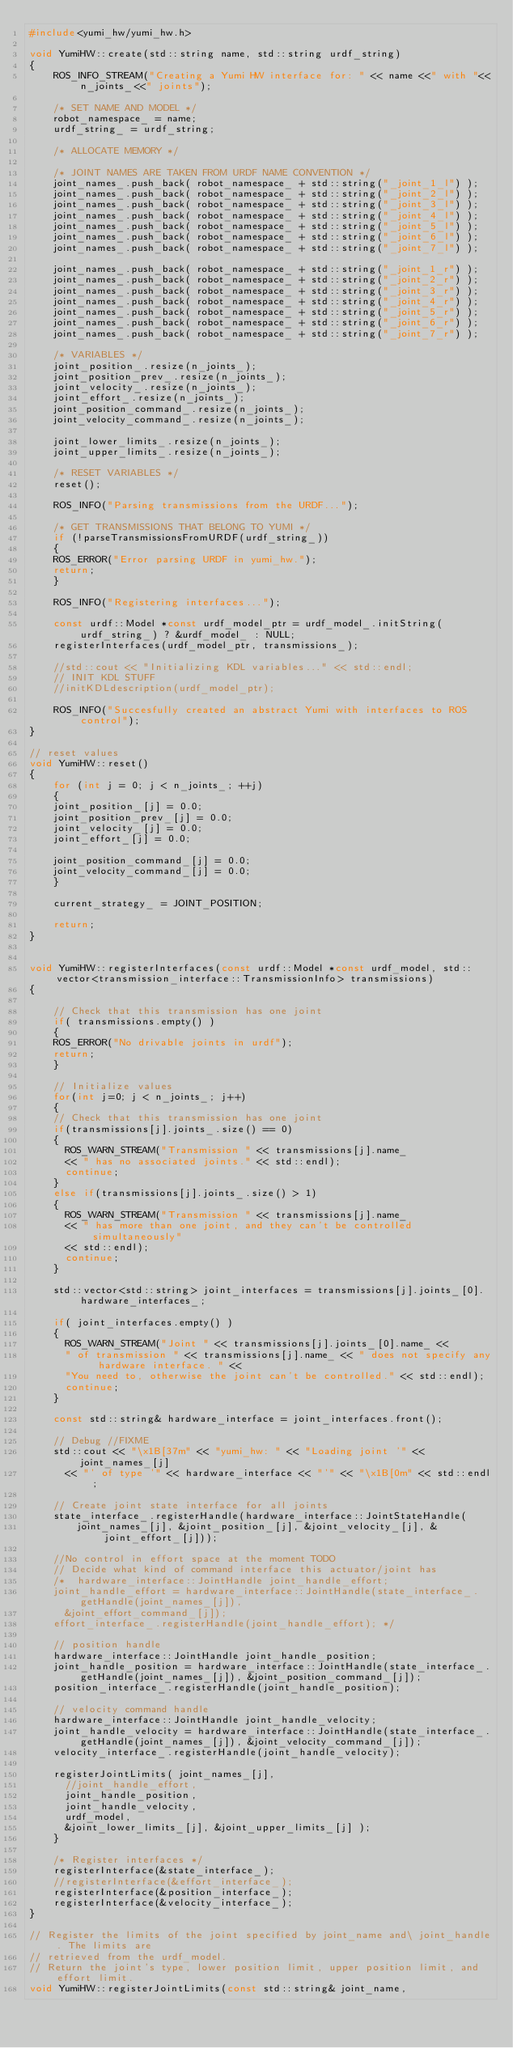<code> <loc_0><loc_0><loc_500><loc_500><_C++_>#include<yumi_hw/yumi_hw.h>

void YumiHW::create(std::string name, std::string urdf_string)
{
    ROS_INFO_STREAM("Creating a Yumi HW interface for: " << name <<" with "<<n_joints_<<" joints");

    /* SET NAME AND MODEL */
    robot_namespace_ = name;
    urdf_string_ = urdf_string;

    /* ALLOCATE MEMORY */

    /* JOINT NAMES ARE TAKEN FROM URDF NAME CONVENTION */
    joint_names_.push_back( robot_namespace_ + std::string("_joint_1_l") );
    joint_names_.push_back( robot_namespace_ + std::string("_joint_2_l") );
    joint_names_.push_back( robot_namespace_ + std::string("_joint_3_l") );
    joint_names_.push_back( robot_namespace_ + std::string("_joint_4_l") );
    joint_names_.push_back( robot_namespace_ + std::string("_joint_5_l") );
    joint_names_.push_back( robot_namespace_ + std::string("_joint_6_l") );
    joint_names_.push_back( robot_namespace_ + std::string("_joint_7_l") );
    
    joint_names_.push_back( robot_namespace_ + std::string("_joint_1_r") );
    joint_names_.push_back( robot_namespace_ + std::string("_joint_2_r") );
    joint_names_.push_back( robot_namespace_ + std::string("_joint_3_r") );
    joint_names_.push_back( robot_namespace_ + std::string("_joint_4_r") );
    joint_names_.push_back( robot_namespace_ + std::string("_joint_5_r") );
    joint_names_.push_back( robot_namespace_ + std::string("_joint_6_r") );
    joint_names_.push_back( robot_namespace_ + std::string("_joint_7_r") );
    
    /* VARIABLES */
    joint_position_.resize(n_joints_);
    joint_position_prev_.resize(n_joints_);
    joint_velocity_.resize(n_joints_);
    joint_effort_.resize(n_joints_);
    joint_position_command_.resize(n_joints_);
    joint_velocity_command_.resize(n_joints_);

    joint_lower_limits_.resize(n_joints_);
    joint_upper_limits_.resize(n_joints_);

    /* RESET VARIABLES */
    reset();

    ROS_INFO("Parsing transmissions from the URDF...");

    /* GET TRANSMISSIONS THAT BELONG TO YUMI */
    if (!parseTransmissionsFromURDF(urdf_string_))
    {
		ROS_ERROR("Error parsing URDF in yumi_hw.");
		return;
    }

    ROS_INFO("Registering interfaces...");

    const urdf::Model *const urdf_model_ptr = urdf_model_.initString(urdf_string_) ? &urdf_model_ : NULL;
    registerInterfaces(urdf_model_ptr, transmissions_);

    //std::cout << "Initializing KDL variables..." << std::endl;
    // INIT KDL STUFF
    //initKDLdescription(urdf_model_ptr);

    ROS_INFO("Succesfully created an abstract Yumi with interfaces to ROS control");
}

// reset values
void YumiHW::reset()
{
    for (int j = 0; j < n_joints_; ++j)
    {
		joint_position_[j] = 0.0;
		joint_position_prev_[j] = 0.0;
		joint_velocity_[j] = 0.0;
		joint_effort_[j] = 0.0;

		joint_position_command_[j] = 0.0;
		joint_velocity_command_[j] = 0.0;
    }

    current_strategy_ = JOINT_POSITION;

    return;
}


void YumiHW::registerInterfaces(const urdf::Model *const urdf_model, std::vector<transmission_interface::TransmissionInfo> transmissions)
{

    // Check that this transmission has one joint
    if( transmissions.empty() )
    {
		ROS_ERROR("No drivable joints in urdf");
		return;
    }

    // Initialize values
    for(int j=0; j < n_joints_; j++)
    {
		// Check that this transmission has one joint
		if(transmissions[j].joints_.size() == 0)
		{
			ROS_WARN_STREAM("Transmission " << transmissions[j].name_
			<< " has no associated joints." << std::endl);
			continue;
		}
		else if(transmissions[j].joints_.size() > 1)
		{
			ROS_WARN_STREAM("Transmission " << transmissions[j].name_
			<< " has more than one joint, and they can't be controlled simultaneously"
			<< std::endl);
			continue;
		}

		std::vector<std::string> joint_interfaces = transmissions[j].joints_[0].hardware_interfaces_;

		if( joint_interfaces.empty() )
		{
			ROS_WARN_STREAM("Joint " << transmissions[j].joints_[0].name_ <<
			" of transmission " << transmissions[j].name_ << " does not specify any hardware interface. " <<
			"You need to, otherwise the joint can't be controlled." << std::endl);
			continue;
		}

		const std::string& hardware_interface = joint_interfaces.front();

		// Debug //FIXME
		std::cout << "\x1B[37m" << "yumi_hw: " << "Loading joint '" << joint_names_[j]
			<< "' of type '" << hardware_interface << "'" << "\x1B[0m" << std::endl;

		// Create joint state interface for all joints
		state_interface_.registerHandle(hardware_interface::JointStateHandle(
				joint_names_[j], &joint_position_[j], &joint_velocity_[j], &joint_effort_[j]));

		//No control in effort space at the moment TODO
		// Decide what kind of command interface this actuator/joint has
		/*	hardware_interface::JointHandle joint_handle_effort;
		joint_handle_effort = hardware_interface::JointHandle(state_interface_.getHandle(joint_names_[j]),
			&joint_effort_command_[j]);
		effort_interface_.registerHandle(joint_handle_effort); */

		// position handle
		hardware_interface::JointHandle joint_handle_position;
		joint_handle_position = hardware_interface::JointHandle(state_interface_.getHandle(joint_names_[j]), &joint_position_command_[j]);
		position_interface_.registerHandle(joint_handle_position);

		// velocity command handle
		hardware_interface::JointHandle joint_handle_velocity;
		joint_handle_velocity = hardware_interface::JointHandle(state_interface_.getHandle(joint_names_[j]), &joint_velocity_command_[j]);
		velocity_interface_.registerHandle(joint_handle_velocity);

		registerJointLimits( joint_names_[j],
			//joint_handle_effort,
			joint_handle_position,
			joint_handle_velocity,
			urdf_model,
			&joint_lower_limits_[j], &joint_upper_limits_[j] );
    }

    /* Register interfaces */
    registerInterface(&state_interface_);
    //registerInterface(&effort_interface_);
    registerInterface(&position_interface_);
    registerInterface(&velocity_interface_);
}

// Register the limits of the joint specified by joint_name and\ joint_handle. The limits are
// retrieved from the urdf_model.
// Return the joint's type, lower position limit, upper position limit, and effort limit.
void YumiHW::registerJointLimits(const std::string& joint_name,</code> 